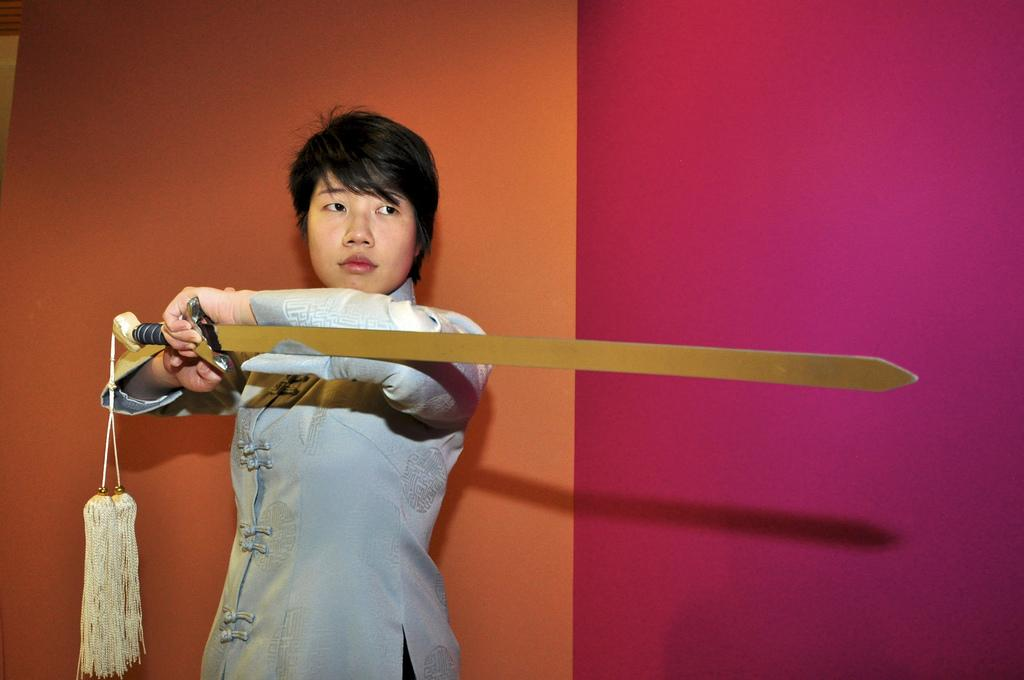Who or what is the main subject in the image? There is a person in the center of the image. What is the person holding in the image? The person is holding a sword. What can be seen in the background of the image? There is a wall in the background of the image. How many letters are on the bed in the image? There is no bed or letters present in the image. What type of duck can be seen swimming in the image? There is no duck present in the image. 